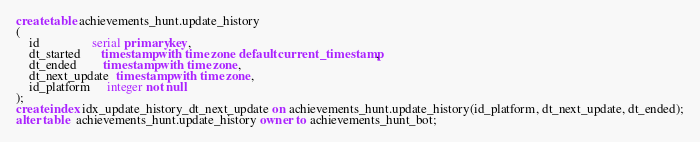<code> <loc_0><loc_0><loc_500><loc_500><_SQL_>create table achievements_hunt.update_history
(
    id 			    serial primary key,
    dt_started      timestamp with time zone default current_timestamp,
    dt_ended        timestamp with time zone,
    dt_next_update  timestamp with time zone,
    id_platform     integer not null
);
create index idx_update_history_dt_next_update on achievements_hunt.update_history(id_platform, dt_next_update, dt_ended);
alter table  achievements_hunt.update_history owner to achievements_hunt_bot;</code> 